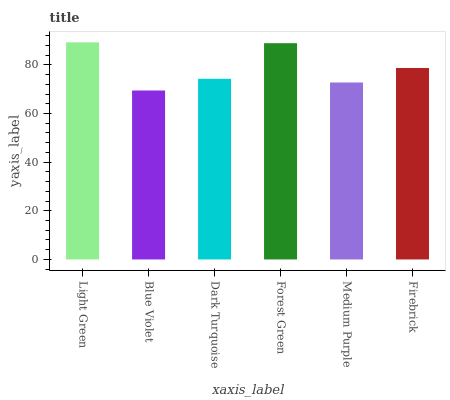Is Blue Violet the minimum?
Answer yes or no. Yes. Is Light Green the maximum?
Answer yes or no. Yes. Is Dark Turquoise the minimum?
Answer yes or no. No. Is Dark Turquoise the maximum?
Answer yes or no. No. Is Dark Turquoise greater than Blue Violet?
Answer yes or no. Yes. Is Blue Violet less than Dark Turquoise?
Answer yes or no. Yes. Is Blue Violet greater than Dark Turquoise?
Answer yes or no. No. Is Dark Turquoise less than Blue Violet?
Answer yes or no. No. Is Firebrick the high median?
Answer yes or no. Yes. Is Dark Turquoise the low median?
Answer yes or no. Yes. Is Light Green the high median?
Answer yes or no. No. Is Blue Violet the low median?
Answer yes or no. No. 